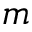<formula> <loc_0><loc_0><loc_500><loc_500>m</formula> 